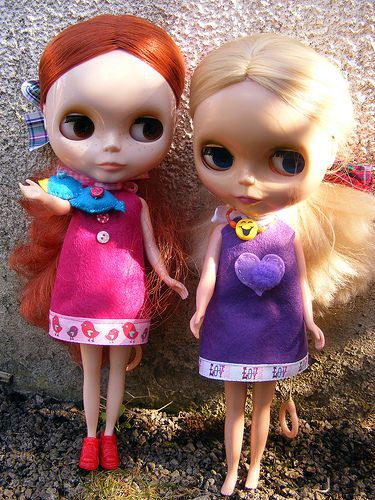<image>
Is there a dress on the doll? No. The dress is not positioned on the doll. They may be near each other, but the dress is not supported by or resting on top of the doll. Is the toy to the left of the toy? Yes. From this viewpoint, the toy is positioned to the left side relative to the toy. 